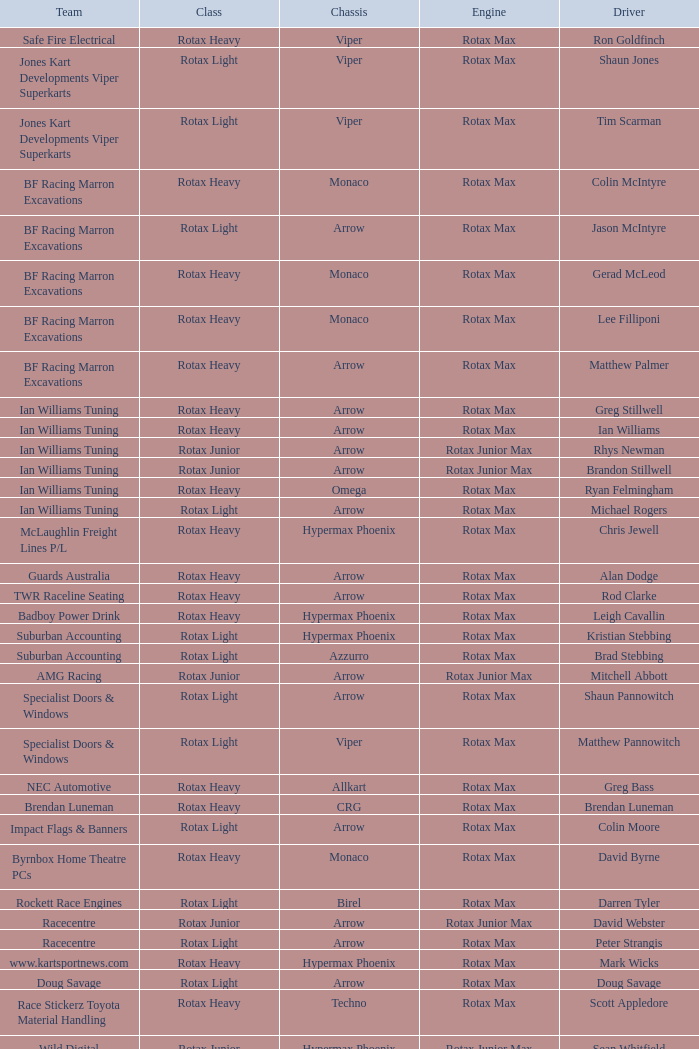What is the name of the team whose class is Rotax Light? Jones Kart Developments Viper Superkarts, Jones Kart Developments Viper Superkarts, BF Racing Marron Excavations, Ian Williams Tuning, Suburban Accounting, Suburban Accounting, Specialist Doors & Windows, Specialist Doors & Windows, Impact Flags & Banners, Rockett Race Engines, Racecentre, Doug Savage. 